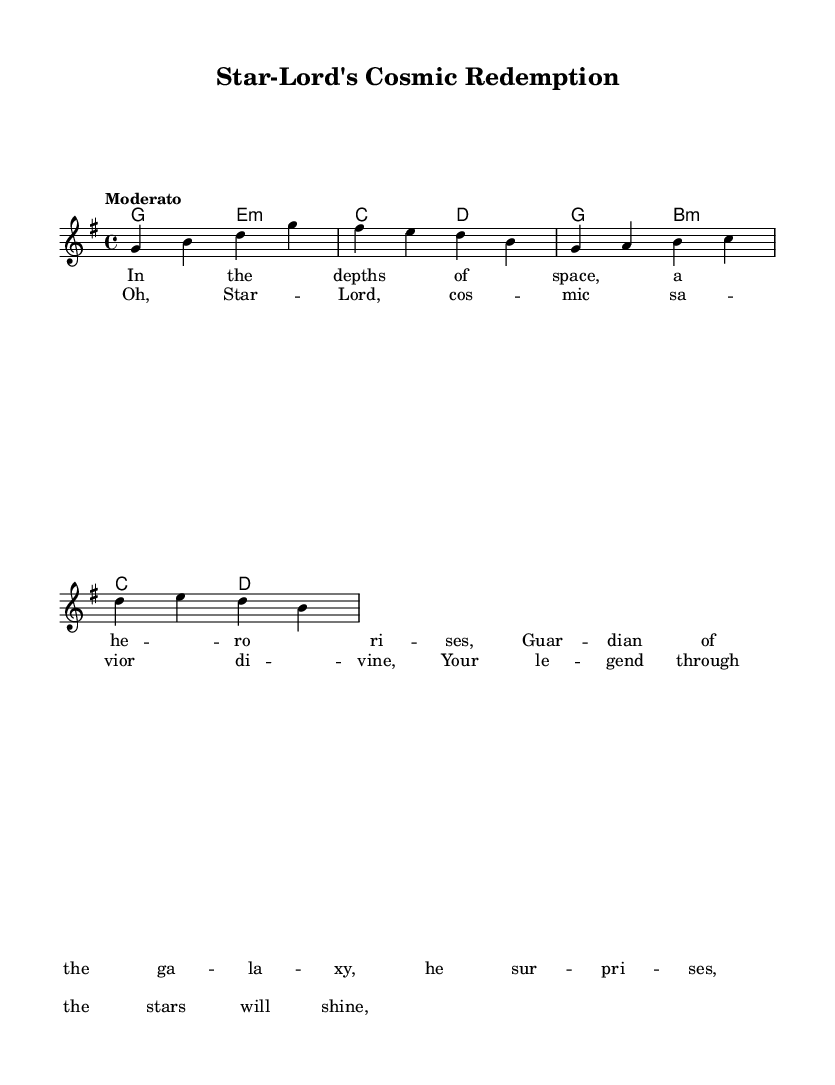What is the key signature of this music? The key signature indicated at the beginning of the music is G major, which has one sharp (F#).
Answer: G major What is the time signature of this music? The time signature shown at the beginning is 4/4, meaning there are four beats in each measure, and a quarter note gets one beat.
Answer: 4/4 What is the tempo marking given in the score? The tempo marking provided is "Moderato," which generally indicates a moderate speed for the piece.
Answer: Moderato What is the primary theme of the verse lyrics? The verse lyrics describe a hero rising in space, implying a heroic and inspiring theme consistent with a space opera narrative.
Answer: Hero rises How many measures are in the melody section? The melody consists of 8 measures, calculated by counting the distinct groups of notes divided by bars in the provided sheet music.
Answer: 8 Which character is mentioned in the chorus lyrics? The chorus lyrics specifically mention "Star-Lord," indicating the focus on this cosmic hero as a savior.
Answer: Star-Lord What type of harmony is used in the score? The harmony section consists of chord changes using a mix of major and minor chords, indicating a typical harmonic progression found in a gospel-infused style.
Answer: Major and minor chords 